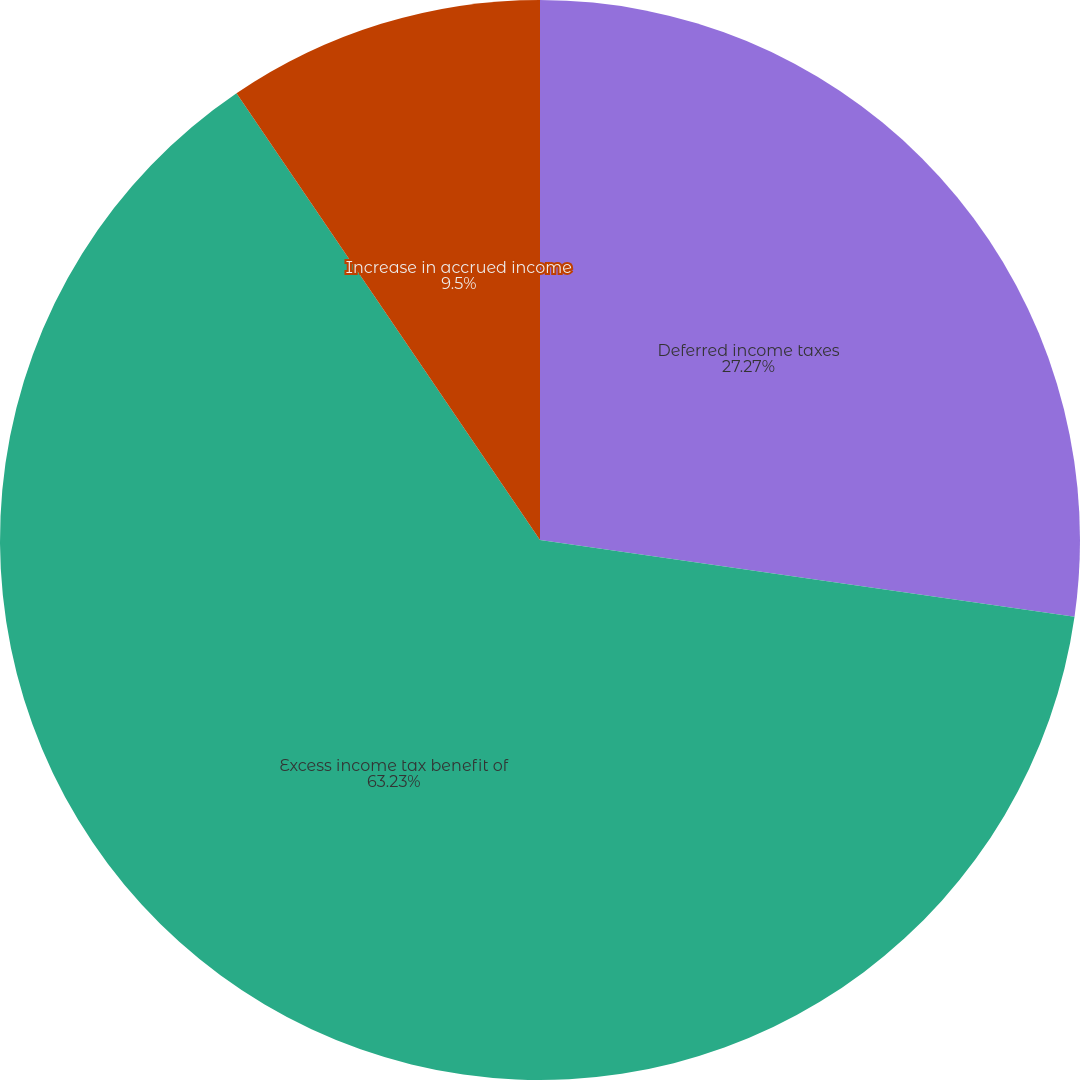<chart> <loc_0><loc_0><loc_500><loc_500><pie_chart><fcel>Deferred income taxes<fcel>Excess income tax benefit of<fcel>Increase in accrued income<nl><fcel>27.27%<fcel>63.24%<fcel>9.5%<nl></chart> 